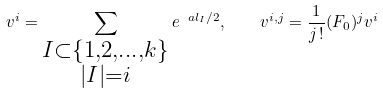<formula> <loc_0><loc_0><loc_500><loc_500>v ^ { i } = \sum _ { \substack { I \subset \{ 1 , 2 , \dots , k \} \\ | I | = i } } e ^ { \ a l _ { I } / 2 } , \quad v ^ { i , j } = \frac { 1 } { j \, ! } ( F _ { 0 } ) ^ { j } v ^ { i }</formula> 